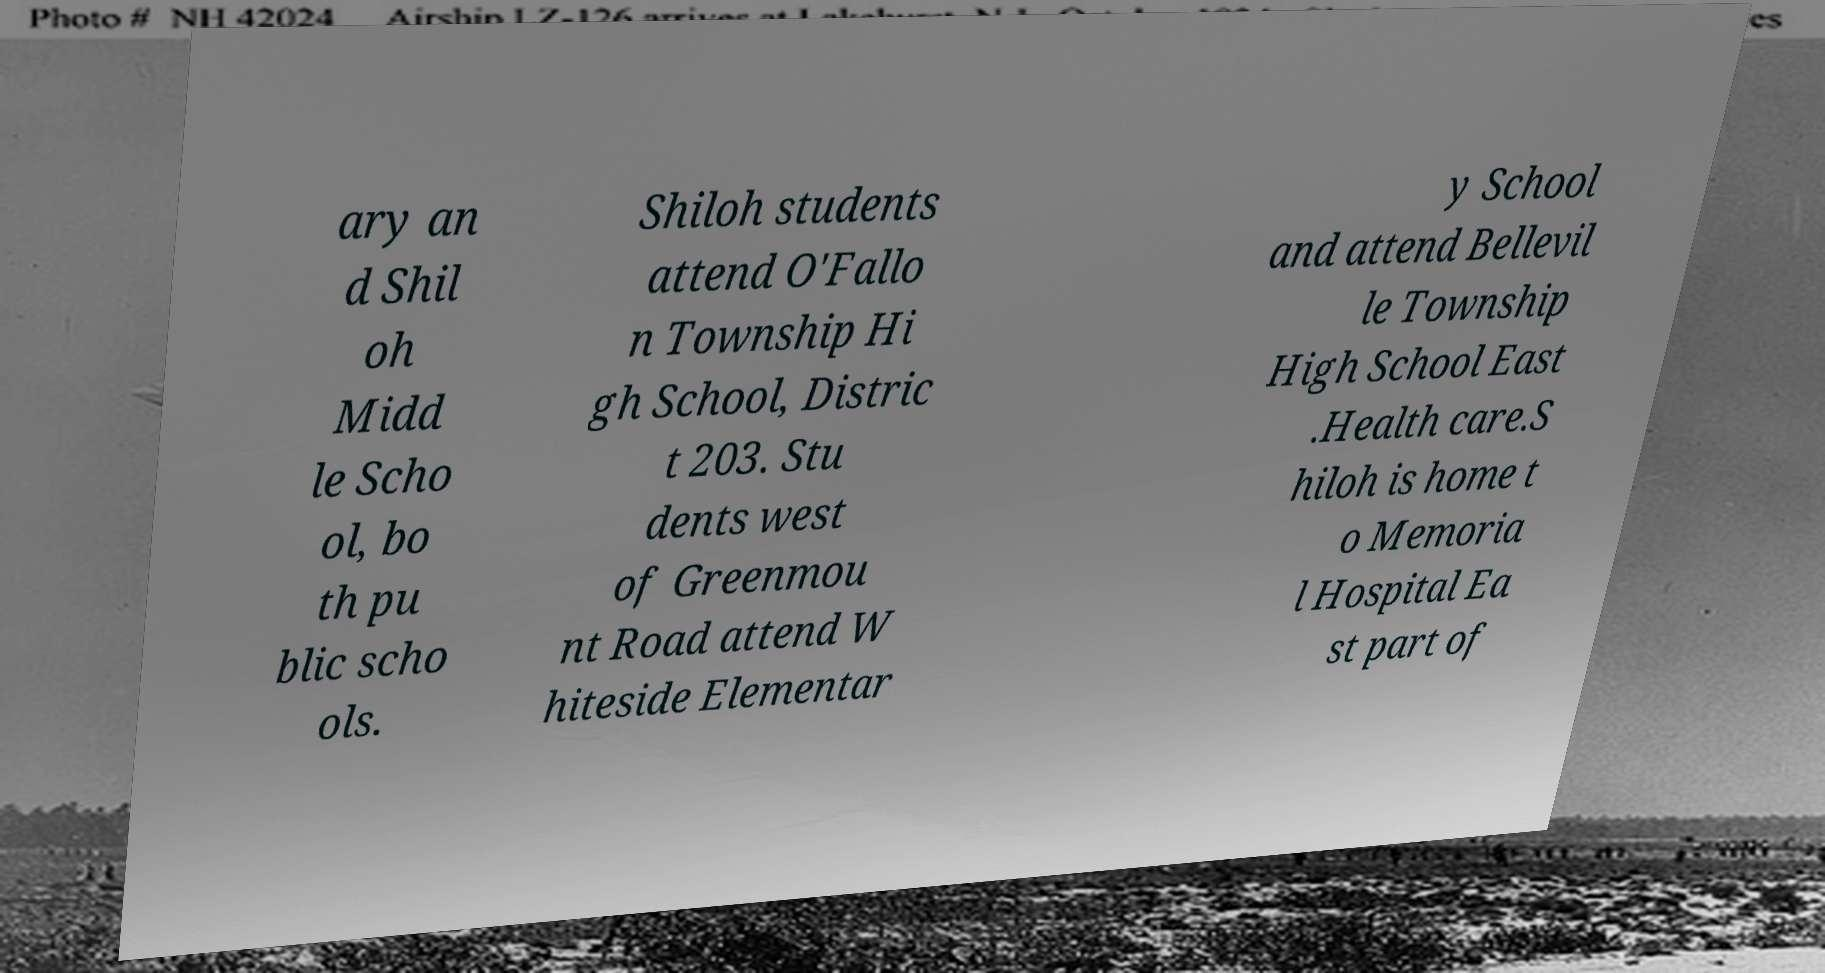Could you extract and type out the text from this image? ary an d Shil oh Midd le Scho ol, bo th pu blic scho ols. Shiloh students attend O'Fallo n Township Hi gh School, Distric t 203. Stu dents west of Greenmou nt Road attend W hiteside Elementar y School and attend Bellevil le Township High School East .Health care.S hiloh is home t o Memoria l Hospital Ea st part of 